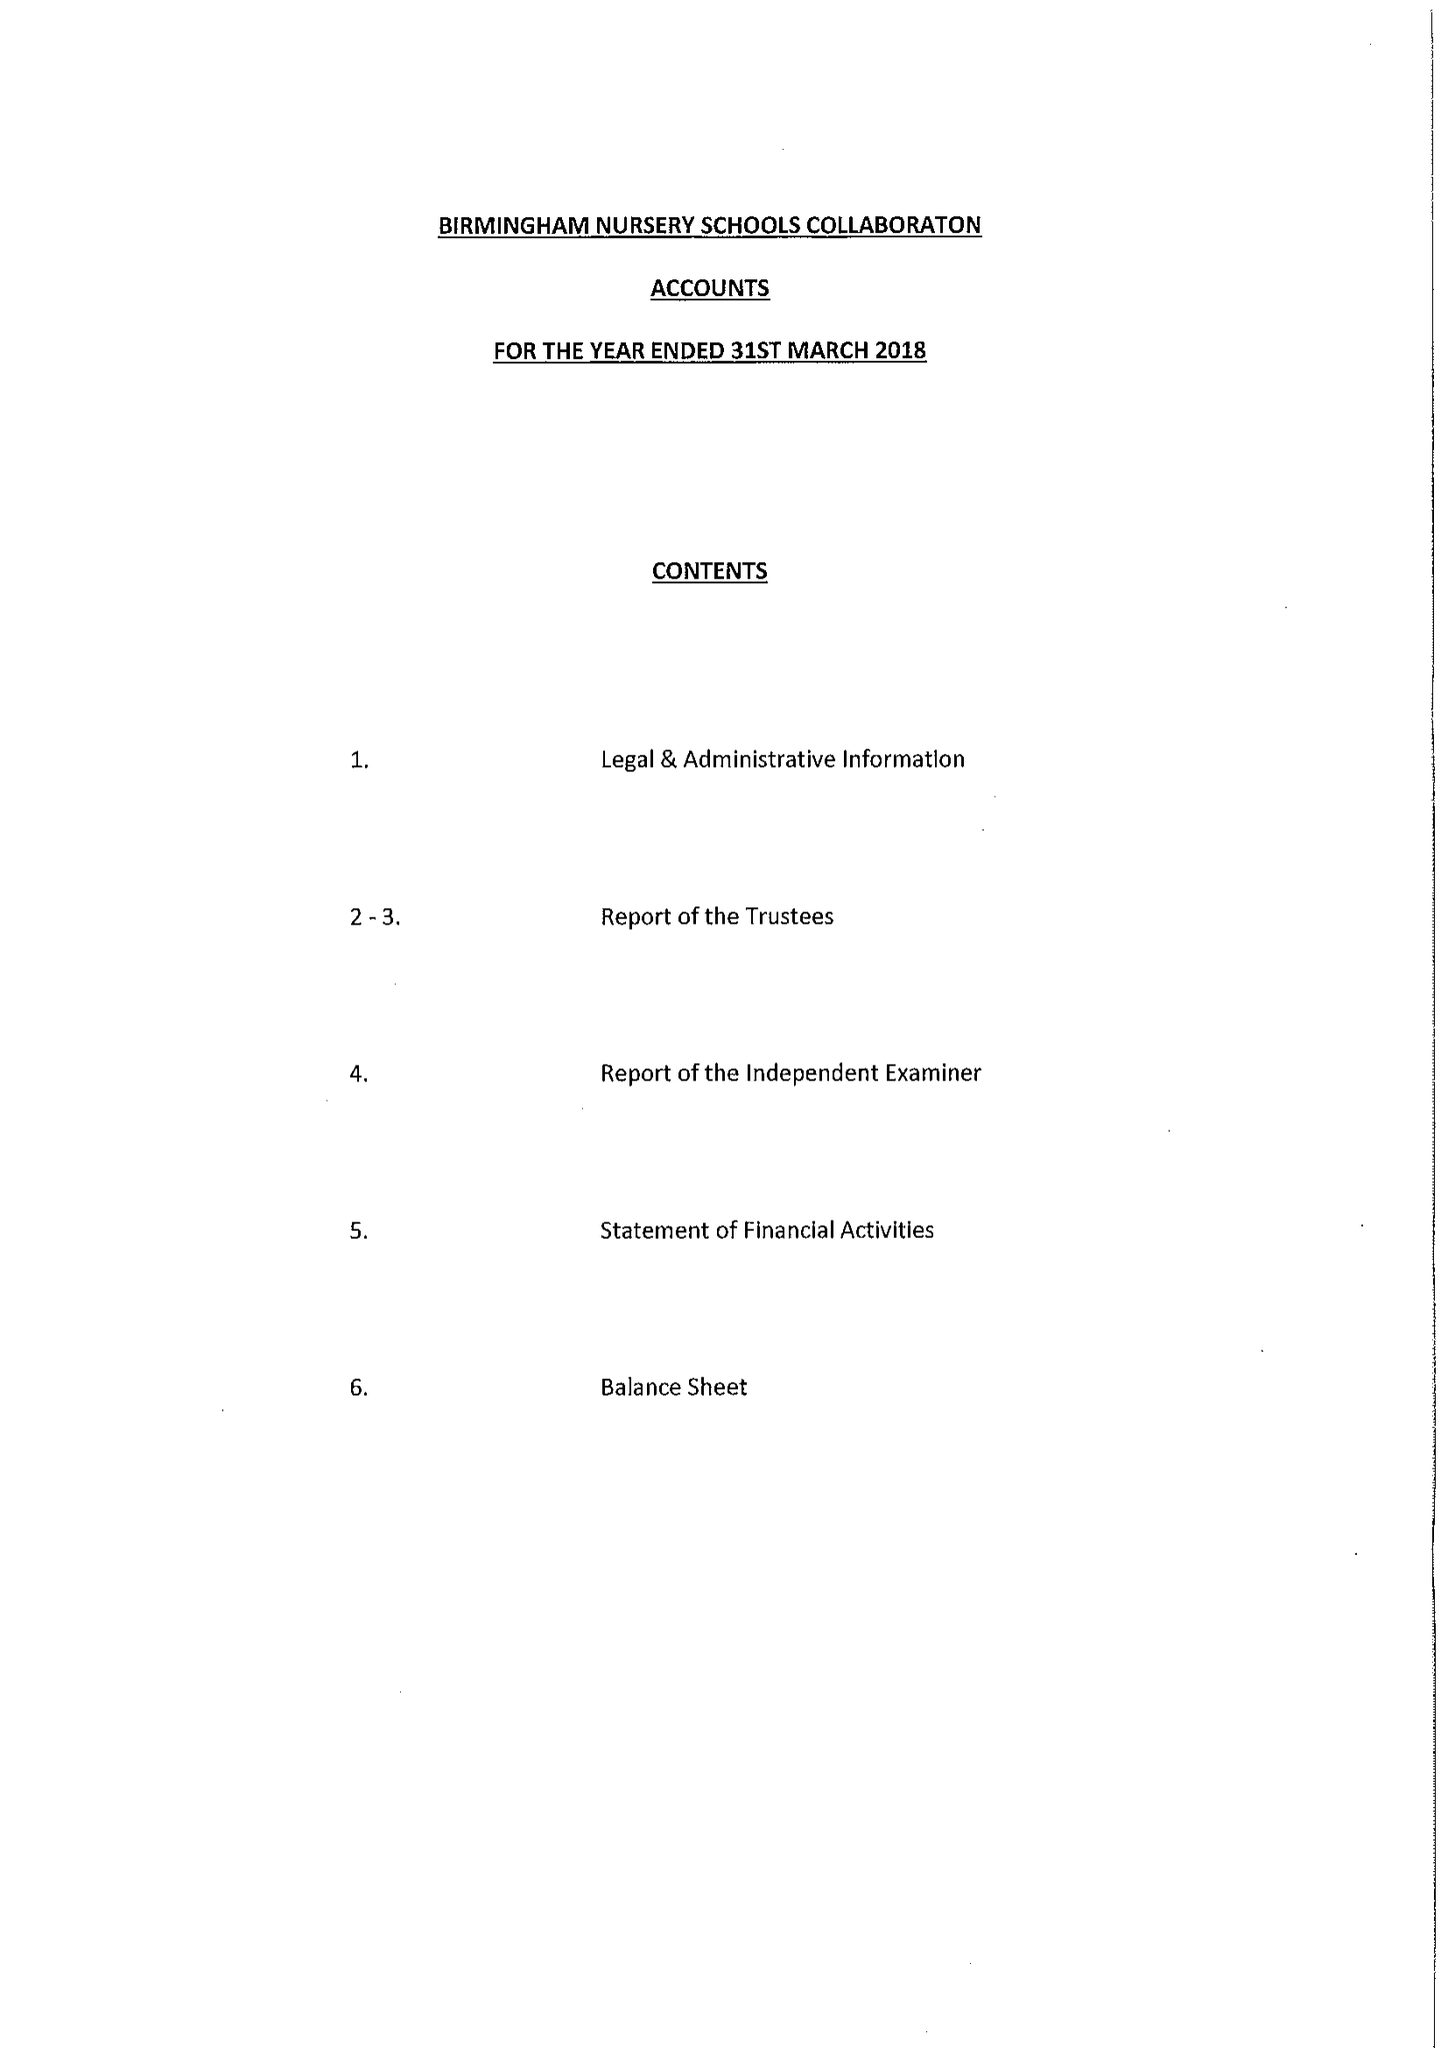What is the value for the income_annually_in_british_pounds?
Answer the question using a single word or phrase. 124787.00 